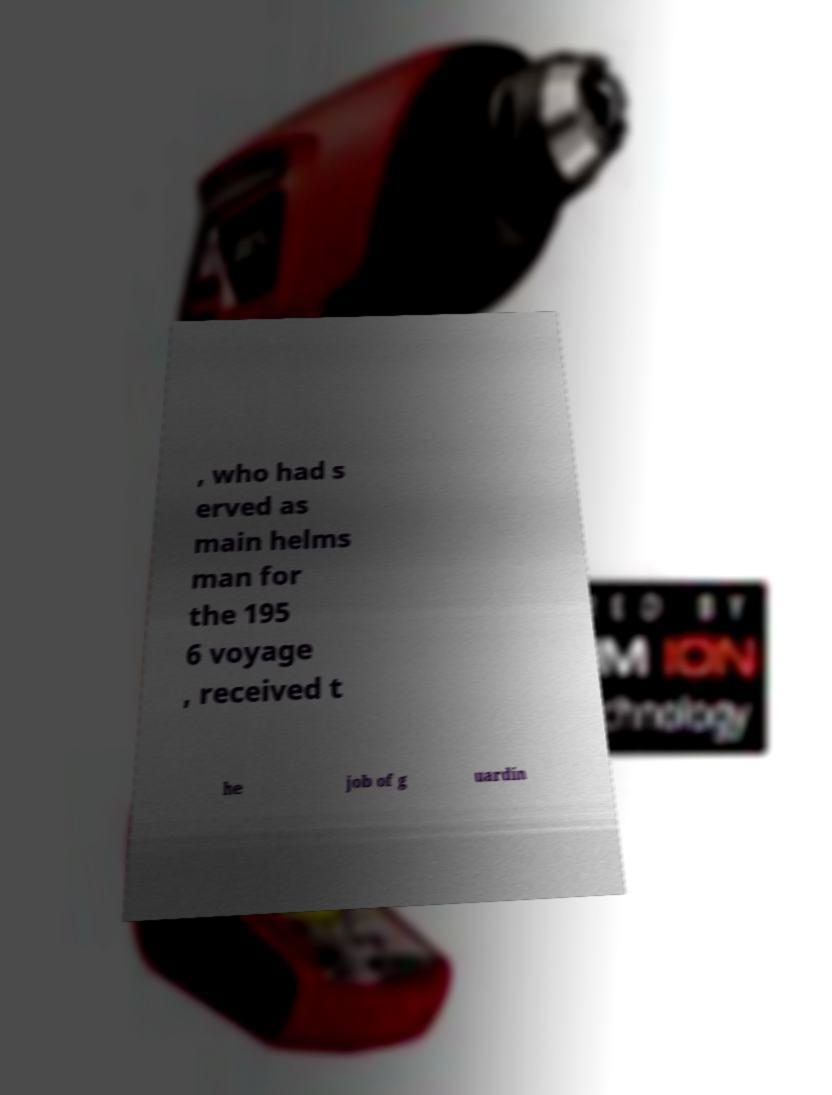Can you accurately transcribe the text from the provided image for me? , who had s erved as main helms man for the 195 6 voyage , received t he job of g uardin 